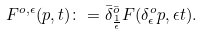Convert formula to latex. <formula><loc_0><loc_0><loc_500><loc_500>F ^ { o , \epsilon } ( p , t ) \colon = \bar { \delta } ^ { \bar { o } } _ { \frac { 1 } { \epsilon } } F ( \delta ^ { o } _ { \epsilon } p , \epsilon t ) .</formula> 